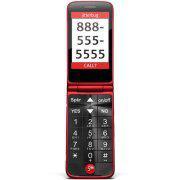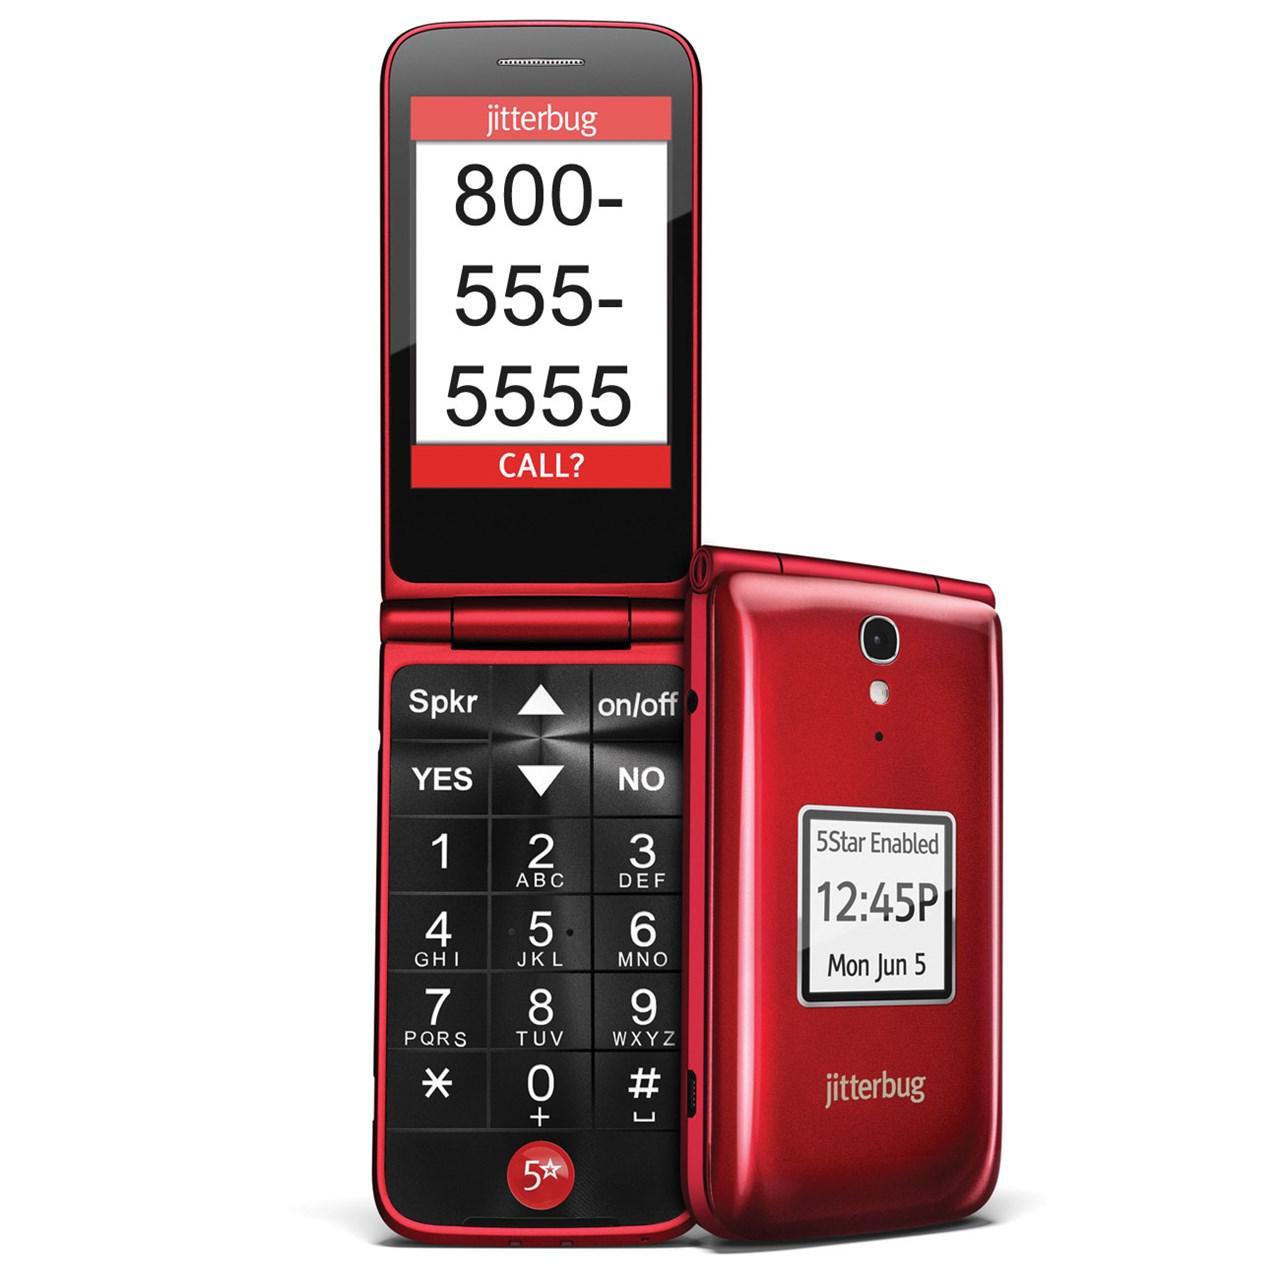The first image is the image on the left, the second image is the image on the right. For the images displayed, is the sentence "One image shows a head-on open flip phone next to a closed phone, and the other image shows a single phone displayed upright and headon." factually correct? Answer yes or no. Yes. The first image is the image on the left, the second image is the image on the right. Analyze the images presented: Is the assertion "Each phone is the same model" valid? Answer yes or no. Yes. 